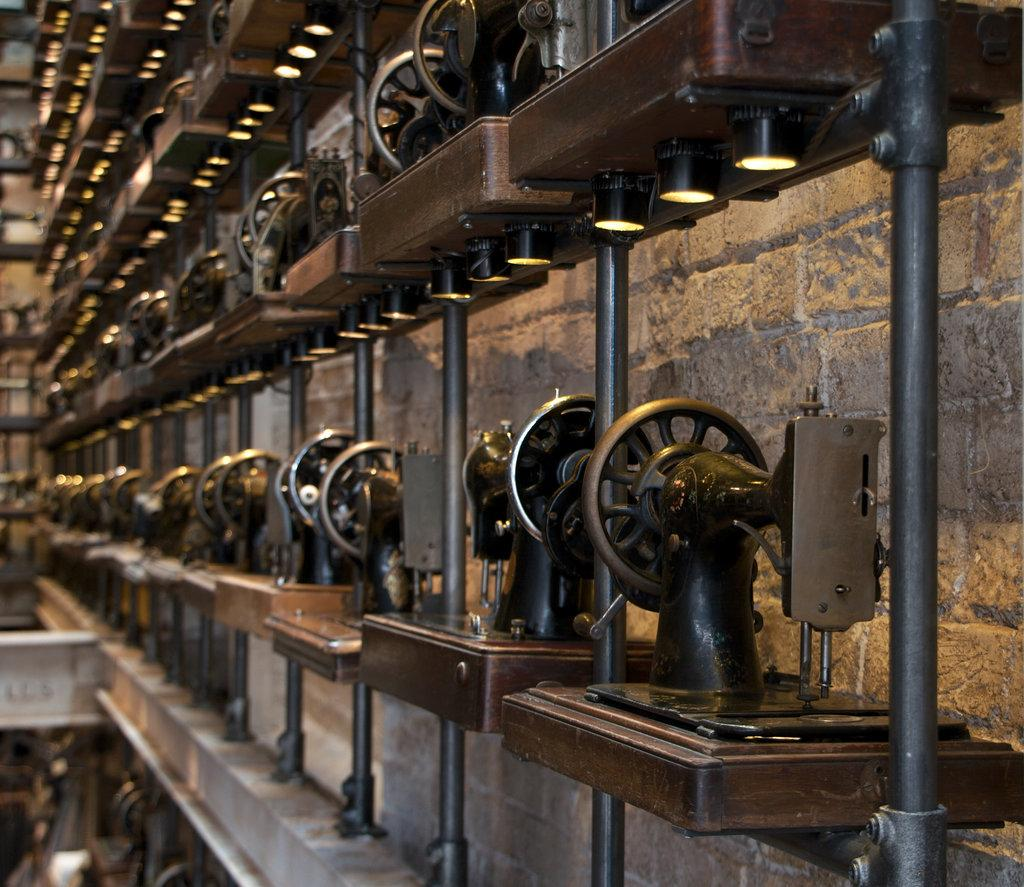What type of equipment can be seen in the image? There are sewing machines in the image. How are the sewing machines arranged? The sewing machines are arranged in a line. What are the rods associated with the sewing machines used for? The rods are likely used for holding fabric or guiding the sewing process. What type of illumination is present at the bottom of each sewing machine? There are lights at the bottom of each sewing machine. What type of religion is being practiced in the image? There is no indication of any religious practice in the image; it features sewing machines arranged in a line with rods and lights. 